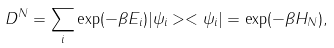Convert formula to latex. <formula><loc_0><loc_0><loc_500><loc_500>D ^ { N } = \sum _ { i } \exp ( - \beta E _ { i } ) | \psi _ { i } > < \psi _ { i } | = \exp ( - \beta H _ { N } ) ,</formula> 